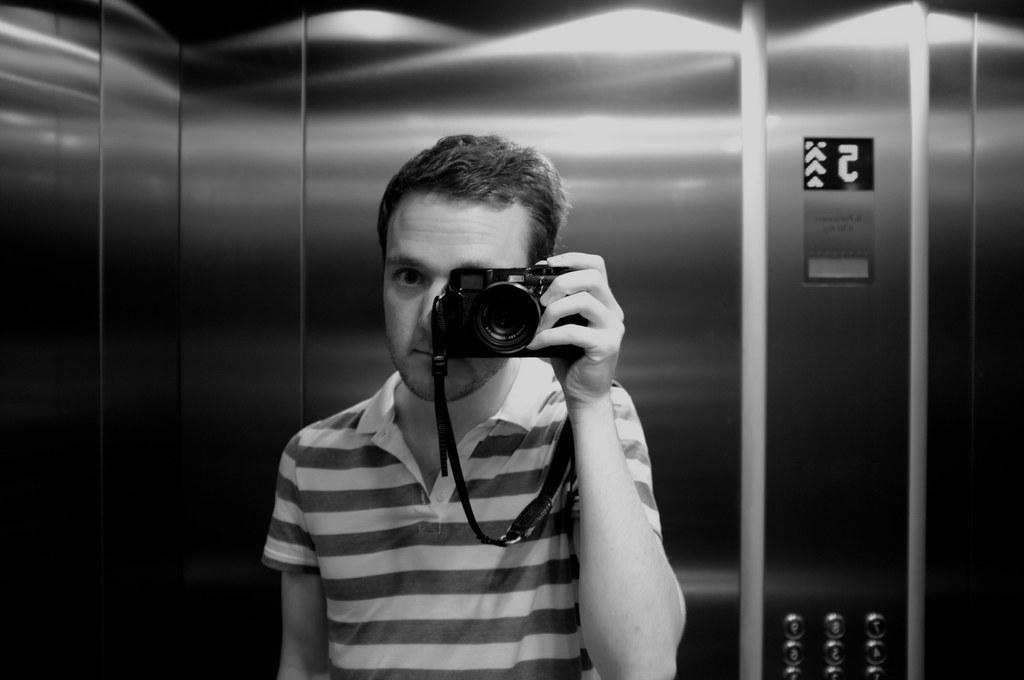Can you describe this image briefly? This picture is taken inside the lift, In this picture in the middle there is a man standing and holding a camera which is in black color, In the background there are doors of the lift which are in black color. 